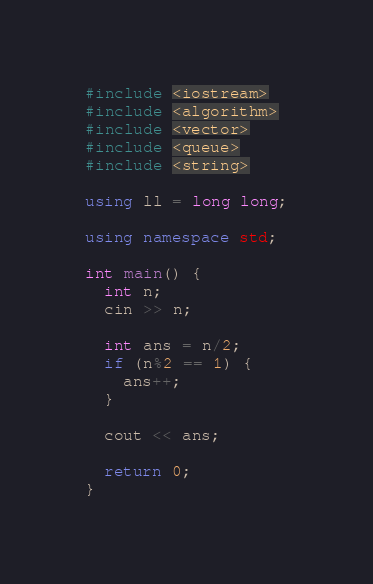Convert code to text. <code><loc_0><loc_0><loc_500><loc_500><_C++_>#include <iostream>
#include <algorithm>
#include <vector>
#include <queue>
#include <string>
 
using ll = long long;
 
using namespace std;
 
int main() {
  int n;
  cin >> n;

  int ans = n/2;
  if (n%2 == 1) {
    ans++;
  }

  cout << ans;

  return 0;
}
</code> 